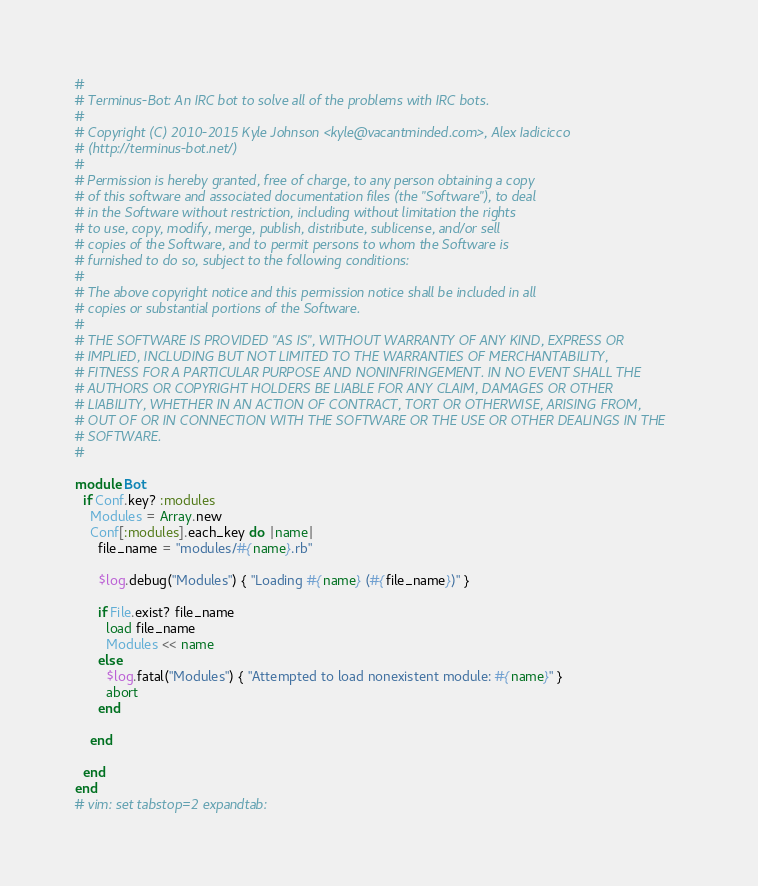<code> <loc_0><loc_0><loc_500><loc_500><_Ruby_>#
# Terminus-Bot: An IRC bot to solve all of the problems with IRC bots.
#
# Copyright (C) 2010-2015 Kyle Johnson <kyle@vacantminded.com>, Alex Iadicicco
# (http://terminus-bot.net/)
#
# Permission is hereby granted, free of charge, to any person obtaining a copy
# of this software and associated documentation files (the "Software"), to deal
# in the Software without restriction, including without limitation the rights
# to use, copy, modify, merge, publish, distribute, sublicense, and/or sell
# copies of the Software, and to permit persons to whom the Software is
# furnished to do so, subject to the following conditions:
#
# The above copyright notice and this permission notice shall be included in all
# copies or substantial portions of the Software.
#
# THE SOFTWARE IS PROVIDED "AS IS", WITHOUT WARRANTY OF ANY KIND, EXPRESS OR
# IMPLIED, INCLUDING BUT NOT LIMITED TO THE WARRANTIES OF MERCHANTABILITY,
# FITNESS FOR A PARTICULAR PURPOSE AND NONINFRINGEMENT. IN NO EVENT SHALL THE
# AUTHORS OR COPYRIGHT HOLDERS BE LIABLE FOR ANY CLAIM, DAMAGES OR OTHER
# LIABILITY, WHETHER IN AN ACTION OF CONTRACT, TORT OR OTHERWISE, ARISING FROM,
# OUT OF OR IN CONNECTION WITH THE SOFTWARE OR THE USE OR OTHER DEALINGS IN THE
# SOFTWARE.
#

module Bot
  if Conf.key? :modules
    Modules = Array.new
    Conf[:modules].each_key do |name|
      file_name = "modules/#{name}.rb"

      $log.debug("Modules") { "Loading #{name} (#{file_name})" }

      if File.exist? file_name
        load file_name
        Modules << name
      else
        $log.fatal("Modules") { "Attempted to load nonexistent module: #{name}" }
        abort
      end

    end

  end
end
# vim: set tabstop=2 expandtab:
</code> 